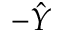Convert formula to latex. <formula><loc_0><loc_0><loc_500><loc_500>- \hat { Y }</formula> 